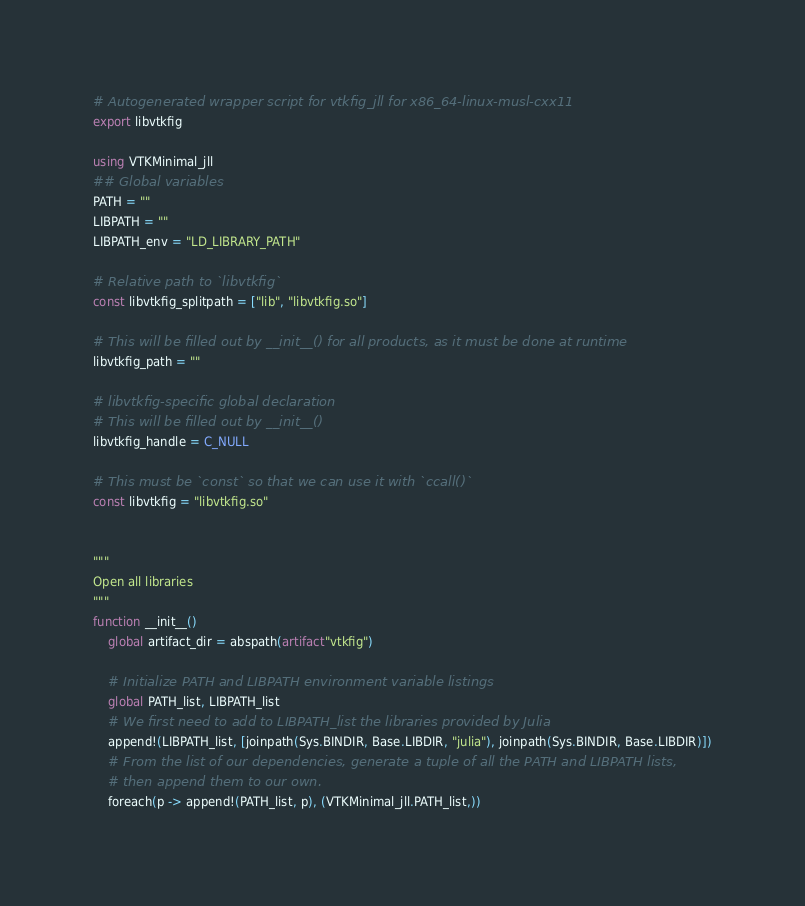Convert code to text. <code><loc_0><loc_0><loc_500><loc_500><_Julia_># Autogenerated wrapper script for vtkfig_jll for x86_64-linux-musl-cxx11
export libvtkfig

using VTKMinimal_jll
## Global variables
PATH = ""
LIBPATH = ""
LIBPATH_env = "LD_LIBRARY_PATH"

# Relative path to `libvtkfig`
const libvtkfig_splitpath = ["lib", "libvtkfig.so"]

# This will be filled out by __init__() for all products, as it must be done at runtime
libvtkfig_path = ""

# libvtkfig-specific global declaration
# This will be filled out by __init__()
libvtkfig_handle = C_NULL

# This must be `const` so that we can use it with `ccall()`
const libvtkfig = "libvtkfig.so"


"""
Open all libraries
"""
function __init__()
    global artifact_dir = abspath(artifact"vtkfig")

    # Initialize PATH and LIBPATH environment variable listings
    global PATH_list, LIBPATH_list
    # We first need to add to LIBPATH_list the libraries provided by Julia
    append!(LIBPATH_list, [joinpath(Sys.BINDIR, Base.LIBDIR, "julia"), joinpath(Sys.BINDIR, Base.LIBDIR)])
    # From the list of our dependencies, generate a tuple of all the PATH and LIBPATH lists,
    # then append them to our own.
    foreach(p -> append!(PATH_list, p), (VTKMinimal_jll.PATH_list,))</code> 